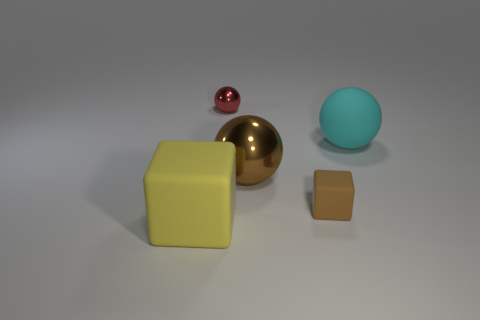What number of things are either brown rubber objects that are on the right side of the large brown thing or yellow cylinders?
Make the answer very short. 1. Is the number of red shiny cylinders less than the number of small matte things?
Ensure brevity in your answer.  Yes. What shape is the yellow object that is made of the same material as the tiny brown cube?
Your response must be concise. Cube. There is a large cyan thing; are there any spheres on the left side of it?
Provide a succinct answer. Yes. Are there fewer tiny red metal spheres that are behind the small red metal sphere than tiny brown rubber things?
Keep it short and to the point. Yes. What is the big brown object made of?
Offer a terse response. Metal. What is the color of the tiny rubber thing?
Offer a very short reply. Brown. What color is the ball that is both behind the large brown thing and to the left of the tiny block?
Provide a succinct answer. Red. Are the big cyan thing and the big object in front of the small brown rubber block made of the same material?
Give a very brief answer. Yes. There is a rubber thing left of the metal object that is in front of the big cyan rubber object; what size is it?
Your response must be concise. Large. 